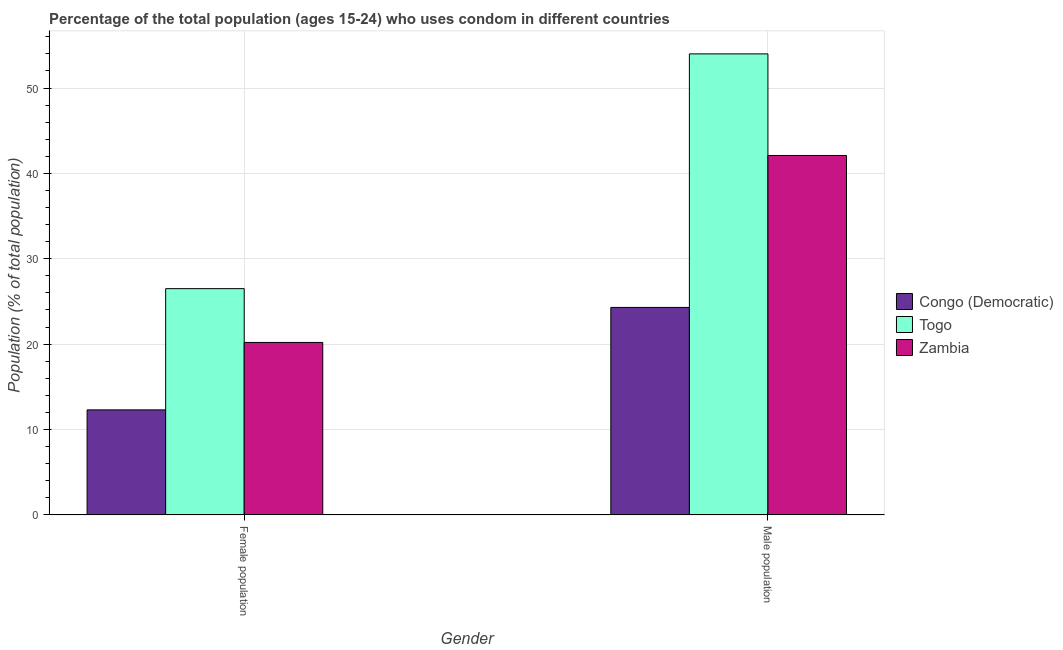Are the number of bars per tick equal to the number of legend labels?
Ensure brevity in your answer.  Yes. How many bars are there on the 1st tick from the right?
Your response must be concise. 3. What is the label of the 1st group of bars from the left?
Your answer should be very brief. Female population. What is the female population in Zambia?
Provide a short and direct response. 20.2. Across all countries, what is the minimum male population?
Offer a terse response. 24.3. In which country was the female population maximum?
Your answer should be compact. Togo. In which country was the male population minimum?
Keep it short and to the point. Congo (Democratic). What is the difference between the male population in Congo (Democratic) and that in Zambia?
Provide a succinct answer. -17.8. What is the difference between the male population in Togo and the female population in Zambia?
Offer a very short reply. 33.8. What is the average female population per country?
Offer a terse response. 19.67. What is the ratio of the female population in Zambia to that in Congo (Democratic)?
Offer a terse response. 1.64. Is the female population in Congo (Democratic) less than that in Togo?
Ensure brevity in your answer.  Yes. In how many countries, is the male population greater than the average male population taken over all countries?
Provide a succinct answer. 2. What does the 1st bar from the left in Female population represents?
Offer a terse response. Congo (Democratic). What does the 2nd bar from the right in Female population represents?
Your answer should be compact. Togo. How many bars are there?
Provide a succinct answer. 6. Are all the bars in the graph horizontal?
Give a very brief answer. No. How many countries are there in the graph?
Give a very brief answer. 3. What is the difference between two consecutive major ticks on the Y-axis?
Ensure brevity in your answer.  10. Are the values on the major ticks of Y-axis written in scientific E-notation?
Offer a very short reply. No. What is the title of the graph?
Your response must be concise. Percentage of the total population (ages 15-24) who uses condom in different countries. What is the label or title of the Y-axis?
Offer a very short reply. Population (% of total population) . What is the Population (% of total population)  in Congo (Democratic) in Female population?
Offer a very short reply. 12.3. What is the Population (% of total population)  in Zambia in Female population?
Give a very brief answer. 20.2. What is the Population (% of total population)  in Congo (Democratic) in Male population?
Make the answer very short. 24.3. What is the Population (% of total population)  of Zambia in Male population?
Provide a succinct answer. 42.1. Across all Gender, what is the maximum Population (% of total population)  of Congo (Democratic)?
Provide a succinct answer. 24.3. Across all Gender, what is the maximum Population (% of total population)  of Zambia?
Provide a short and direct response. 42.1. Across all Gender, what is the minimum Population (% of total population)  in Zambia?
Give a very brief answer. 20.2. What is the total Population (% of total population)  of Congo (Democratic) in the graph?
Your answer should be compact. 36.6. What is the total Population (% of total population)  in Togo in the graph?
Offer a very short reply. 80.5. What is the total Population (% of total population)  of Zambia in the graph?
Offer a very short reply. 62.3. What is the difference between the Population (% of total population)  of Togo in Female population and that in Male population?
Offer a terse response. -27.5. What is the difference between the Population (% of total population)  of Zambia in Female population and that in Male population?
Offer a terse response. -21.9. What is the difference between the Population (% of total population)  in Congo (Democratic) in Female population and the Population (% of total population)  in Togo in Male population?
Your response must be concise. -41.7. What is the difference between the Population (% of total population)  of Congo (Democratic) in Female population and the Population (% of total population)  of Zambia in Male population?
Your response must be concise. -29.8. What is the difference between the Population (% of total population)  in Togo in Female population and the Population (% of total population)  in Zambia in Male population?
Provide a succinct answer. -15.6. What is the average Population (% of total population)  of Togo per Gender?
Provide a succinct answer. 40.25. What is the average Population (% of total population)  of Zambia per Gender?
Offer a very short reply. 31.15. What is the difference between the Population (% of total population)  of Congo (Democratic) and Population (% of total population)  of Togo in Female population?
Your answer should be very brief. -14.2. What is the difference between the Population (% of total population)  of Congo (Democratic) and Population (% of total population)  of Zambia in Female population?
Offer a terse response. -7.9. What is the difference between the Population (% of total population)  of Togo and Population (% of total population)  of Zambia in Female population?
Ensure brevity in your answer.  6.3. What is the difference between the Population (% of total population)  of Congo (Democratic) and Population (% of total population)  of Togo in Male population?
Your answer should be very brief. -29.7. What is the difference between the Population (% of total population)  in Congo (Democratic) and Population (% of total population)  in Zambia in Male population?
Your answer should be compact. -17.8. What is the ratio of the Population (% of total population)  in Congo (Democratic) in Female population to that in Male population?
Give a very brief answer. 0.51. What is the ratio of the Population (% of total population)  in Togo in Female population to that in Male population?
Ensure brevity in your answer.  0.49. What is the ratio of the Population (% of total population)  of Zambia in Female population to that in Male population?
Keep it short and to the point. 0.48. What is the difference between the highest and the second highest Population (% of total population)  in Togo?
Offer a terse response. 27.5. What is the difference between the highest and the second highest Population (% of total population)  in Zambia?
Make the answer very short. 21.9. What is the difference between the highest and the lowest Population (% of total population)  in Congo (Democratic)?
Offer a terse response. 12. What is the difference between the highest and the lowest Population (% of total population)  of Zambia?
Give a very brief answer. 21.9. 